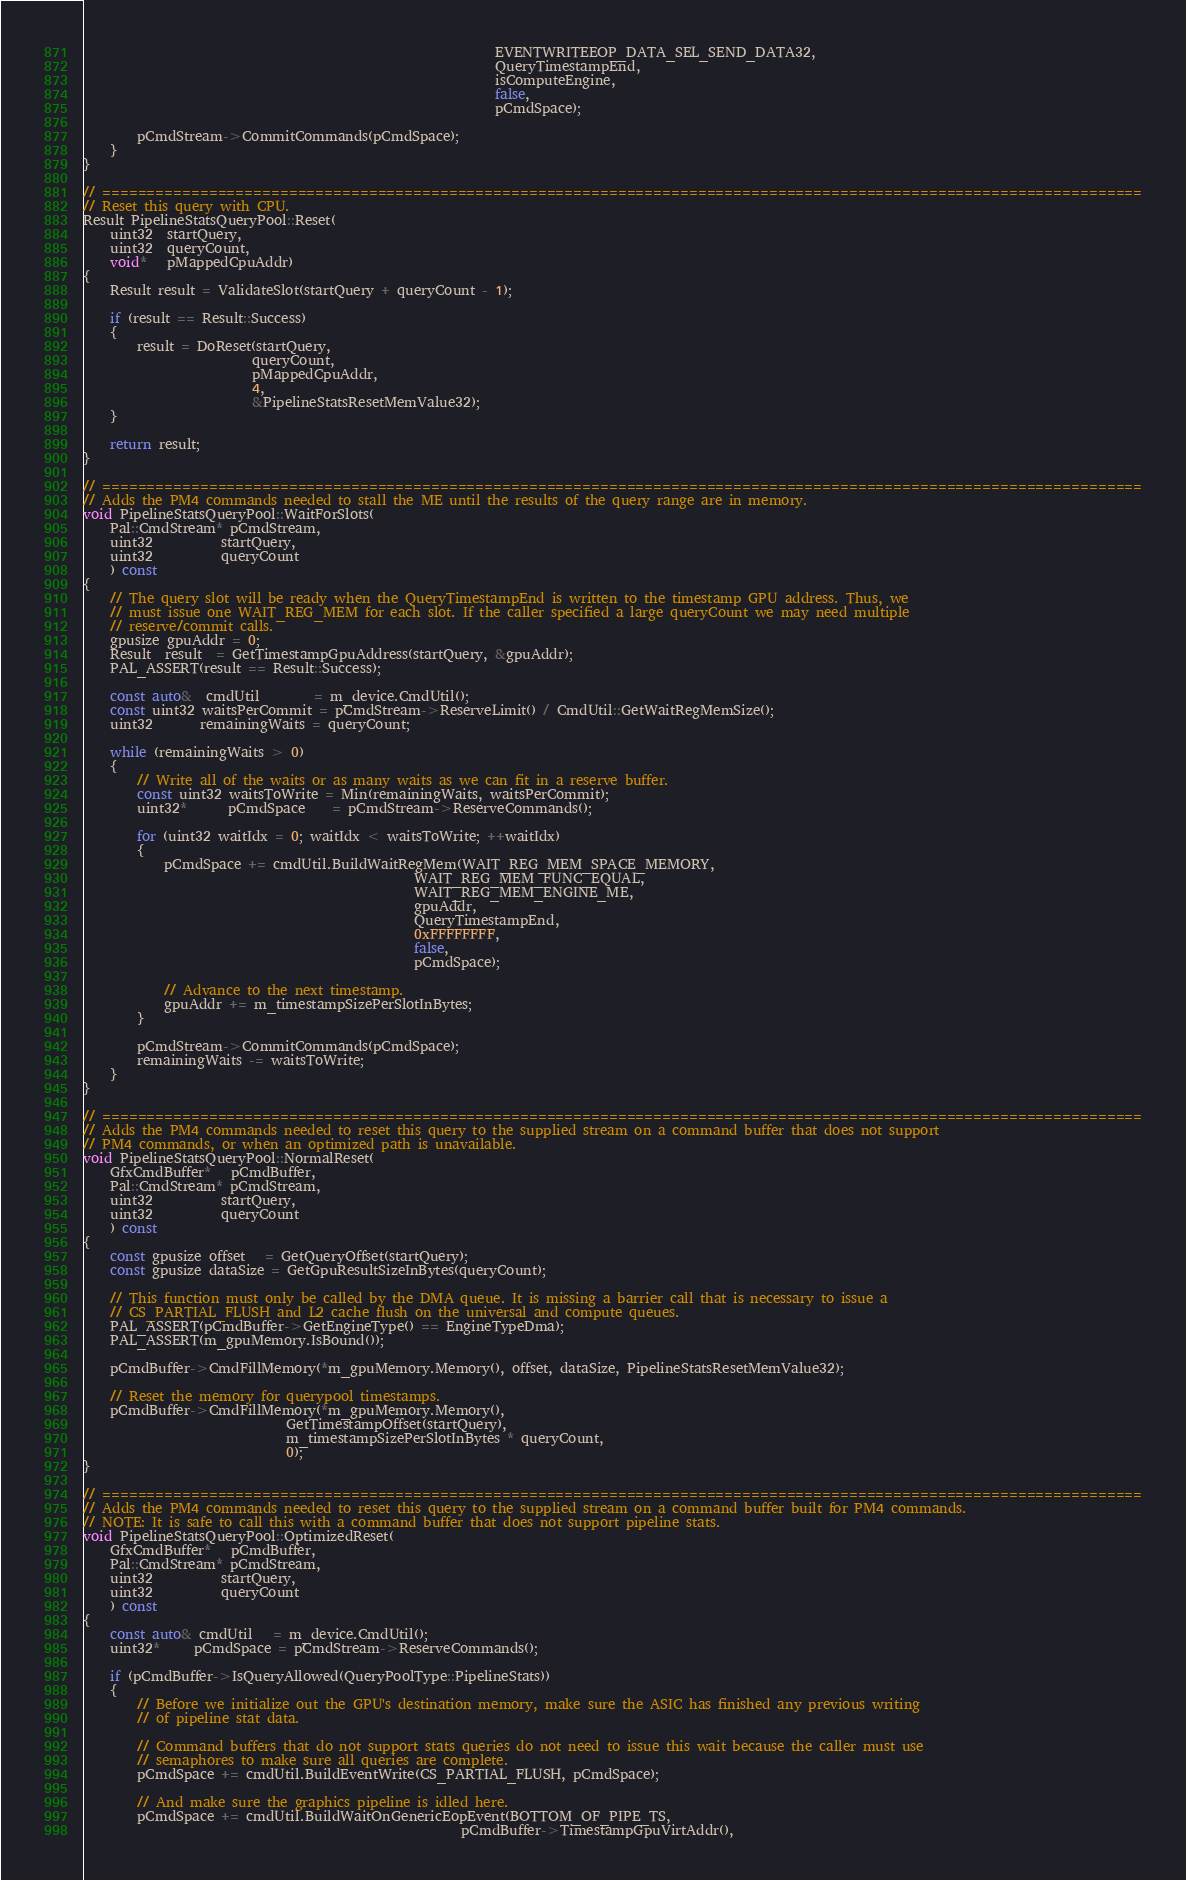Convert code to text. <code><loc_0><loc_0><loc_500><loc_500><_C++_>                                                             EVENTWRITEEOP_DATA_SEL_SEND_DATA32,
                                                             QueryTimestampEnd,
                                                             isComputeEngine,
                                                             false,
                                                             pCmdSpace);

        pCmdStream->CommitCommands(pCmdSpace);
    }
}

// =====================================================================================================================
// Reset this query with CPU.
Result PipelineStatsQueryPool::Reset(
    uint32  startQuery,
    uint32  queryCount,
    void*   pMappedCpuAddr)
{
    Result result = ValidateSlot(startQuery + queryCount - 1);

    if (result == Result::Success)
    {
        result = DoReset(startQuery,
                         queryCount,
                         pMappedCpuAddr,
                         4,
                         &PipelineStatsResetMemValue32);
    }

    return result;
}

// =====================================================================================================================
// Adds the PM4 commands needed to stall the ME until the results of the query range are in memory.
void PipelineStatsQueryPool::WaitForSlots(
    Pal::CmdStream* pCmdStream,
    uint32          startQuery,
    uint32          queryCount
    ) const
{
    // The query slot will be ready when the QueryTimestampEnd is written to the timestamp GPU address. Thus, we
    // must issue one WAIT_REG_MEM for each slot. If the caller specified a large queryCount we may need multiple
    // reserve/commit calls.
    gpusize gpuAddr = 0;
    Result  result  = GetTimestampGpuAddress(startQuery, &gpuAddr);
    PAL_ASSERT(result == Result::Success);

    const auto&  cmdUtil        = m_device.CmdUtil();
    const uint32 waitsPerCommit = pCmdStream->ReserveLimit() / CmdUtil::GetWaitRegMemSize();
    uint32       remainingWaits = queryCount;

    while (remainingWaits > 0)
    {
        // Write all of the waits or as many waits as we can fit in a reserve buffer.
        const uint32 waitsToWrite = Min(remainingWaits, waitsPerCommit);
        uint32*      pCmdSpace    = pCmdStream->ReserveCommands();

        for (uint32 waitIdx = 0; waitIdx < waitsToWrite; ++waitIdx)
        {
            pCmdSpace += cmdUtil.BuildWaitRegMem(WAIT_REG_MEM_SPACE_MEMORY,
                                                 WAIT_REG_MEM_FUNC_EQUAL,
                                                 WAIT_REG_MEM_ENGINE_ME,
                                                 gpuAddr,
                                                 QueryTimestampEnd,
                                                 0xFFFFFFFF,
                                                 false,
                                                 pCmdSpace);

            // Advance to the next timestamp.
            gpuAddr += m_timestampSizePerSlotInBytes;
        }

        pCmdStream->CommitCommands(pCmdSpace);
        remainingWaits -= waitsToWrite;
    }
}

// =====================================================================================================================
// Adds the PM4 commands needed to reset this query to the supplied stream on a command buffer that does not support
// PM4 commands, or when an optimized path is unavailable.
void PipelineStatsQueryPool::NormalReset(
    GfxCmdBuffer*   pCmdBuffer,
    Pal::CmdStream* pCmdStream,
    uint32          startQuery,
    uint32          queryCount
    ) const
{
    const gpusize offset   = GetQueryOffset(startQuery);
    const gpusize dataSize = GetGpuResultSizeInBytes(queryCount);

    // This function must only be called by the DMA queue. It is missing a barrier call that is necessary to issue a
    // CS_PARTIAL_FLUSH and L2 cache flush on the universal and compute queues.
    PAL_ASSERT(pCmdBuffer->GetEngineType() == EngineTypeDma);
    PAL_ASSERT(m_gpuMemory.IsBound());

    pCmdBuffer->CmdFillMemory(*m_gpuMemory.Memory(), offset, dataSize, PipelineStatsResetMemValue32);

    // Reset the memory for querypool timestamps.
    pCmdBuffer->CmdFillMemory(*m_gpuMemory.Memory(),
                              GetTimestampOffset(startQuery),
                              m_timestampSizePerSlotInBytes * queryCount,
                              0);
}

// =====================================================================================================================
// Adds the PM4 commands needed to reset this query to the supplied stream on a command buffer built for PM4 commands.
// NOTE: It is safe to call this with a command buffer that does not support pipeline stats.
void PipelineStatsQueryPool::OptimizedReset(
    GfxCmdBuffer*   pCmdBuffer,
    Pal::CmdStream* pCmdStream,
    uint32          startQuery,
    uint32          queryCount
    ) const
{
    const auto& cmdUtil   = m_device.CmdUtil();
    uint32*     pCmdSpace = pCmdStream->ReserveCommands();

    if (pCmdBuffer->IsQueryAllowed(QueryPoolType::PipelineStats))
    {
        // Before we initialize out the GPU's destination memory, make sure the ASIC has finished any previous writing
        // of pipeline stat data.

        // Command buffers that do not support stats queries do not need to issue this wait because the caller must use
        // semaphores to make sure all queries are complete.
        pCmdSpace += cmdUtil.BuildEventWrite(CS_PARTIAL_FLUSH, pCmdSpace);

        // And make sure the graphics pipeline is idled here.
        pCmdSpace += cmdUtil.BuildWaitOnGenericEopEvent(BOTTOM_OF_PIPE_TS,
                                                        pCmdBuffer->TimestampGpuVirtAddr(),</code> 